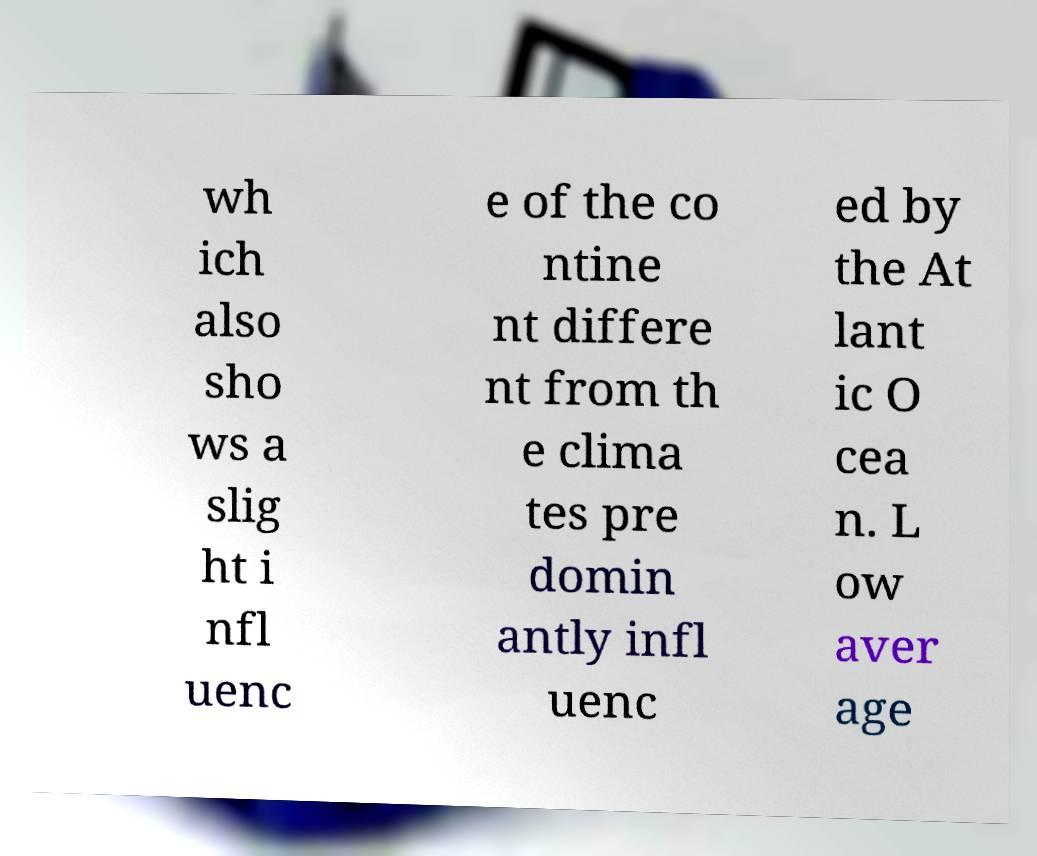For documentation purposes, I need the text within this image transcribed. Could you provide that? wh ich also sho ws a slig ht i nfl uenc e of the co ntine nt differe nt from th e clima tes pre domin antly infl uenc ed by the At lant ic O cea n. L ow aver age 